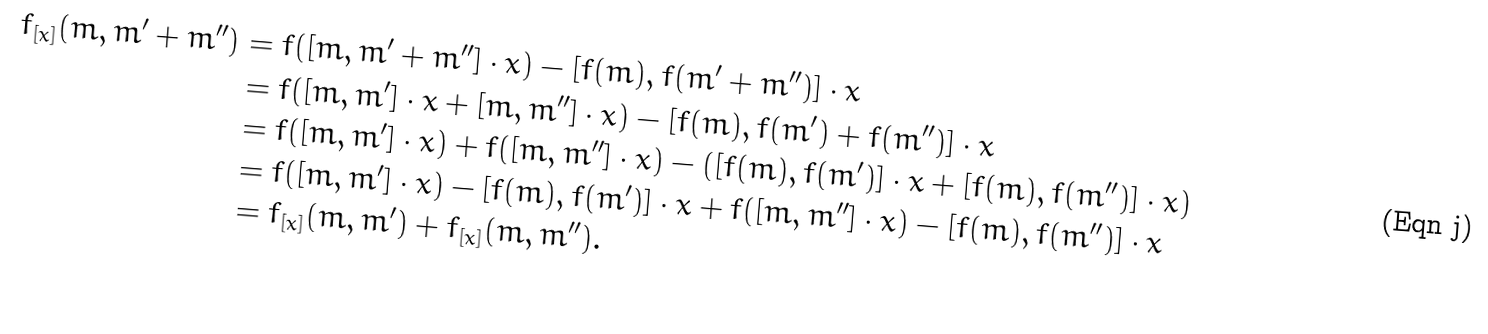<formula> <loc_0><loc_0><loc_500><loc_500>f _ { [ x ] } ( m , m ^ { \prime } + m ^ { \prime \prime } ) & = f ( [ m , m ^ { \prime } + m ^ { \prime \prime } ] \cdot x ) - [ f ( m ) , f ( m ^ { \prime } + m ^ { \prime \prime } ) ] \cdot x \\ & = f ( [ m , m ^ { \prime } ] \cdot x + [ m , m ^ { \prime \prime } ] \cdot x ) - [ f ( m ) , f ( m ^ { \prime } ) + f ( m ^ { \prime \prime } ) ] \cdot x \\ & = f ( [ m , m ^ { \prime } ] \cdot x ) + f ( [ m , m ^ { \prime \prime } ] \cdot x ) - ( [ f ( m ) , f ( m ^ { \prime } ) ] \cdot x + [ f ( m ) , f ( m ^ { \prime \prime } ) ] \cdot x ) \\ & = f ( [ m , m ^ { \prime } ] \cdot x ) - [ f ( m ) , f ( m ^ { \prime } ) ] \cdot x + f ( [ m , m ^ { \prime \prime } ] \cdot x ) - [ f ( m ) , f ( m ^ { \prime \prime } ) ] \cdot x \\ & = f _ { [ x ] } ( m , m ^ { \prime } ) + f _ { [ x ] } ( m , m ^ { \prime \prime } ) .</formula> 